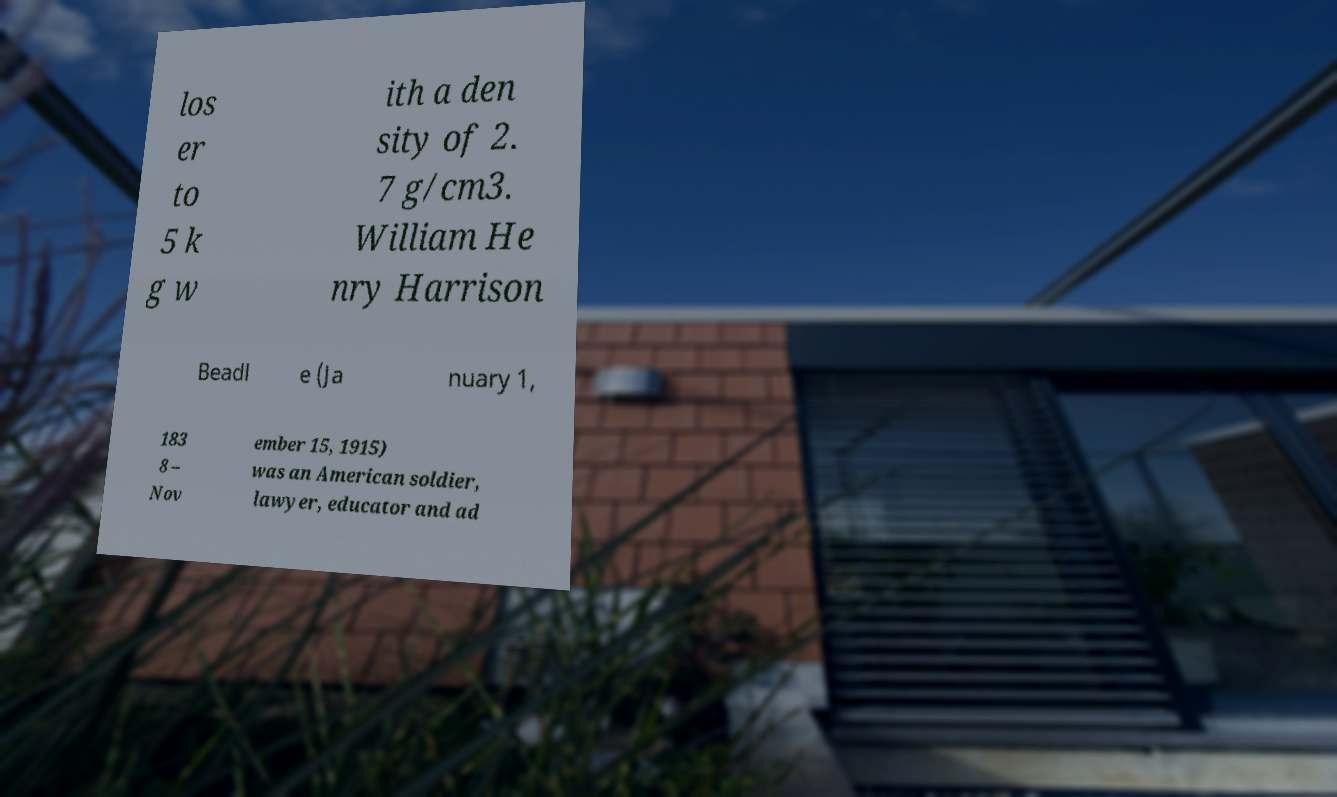Could you extract and type out the text from this image? los er to 5 k g w ith a den sity of 2. 7 g/cm3. William He nry Harrison Beadl e (Ja nuary 1, 183 8 – Nov ember 15, 1915) was an American soldier, lawyer, educator and ad 